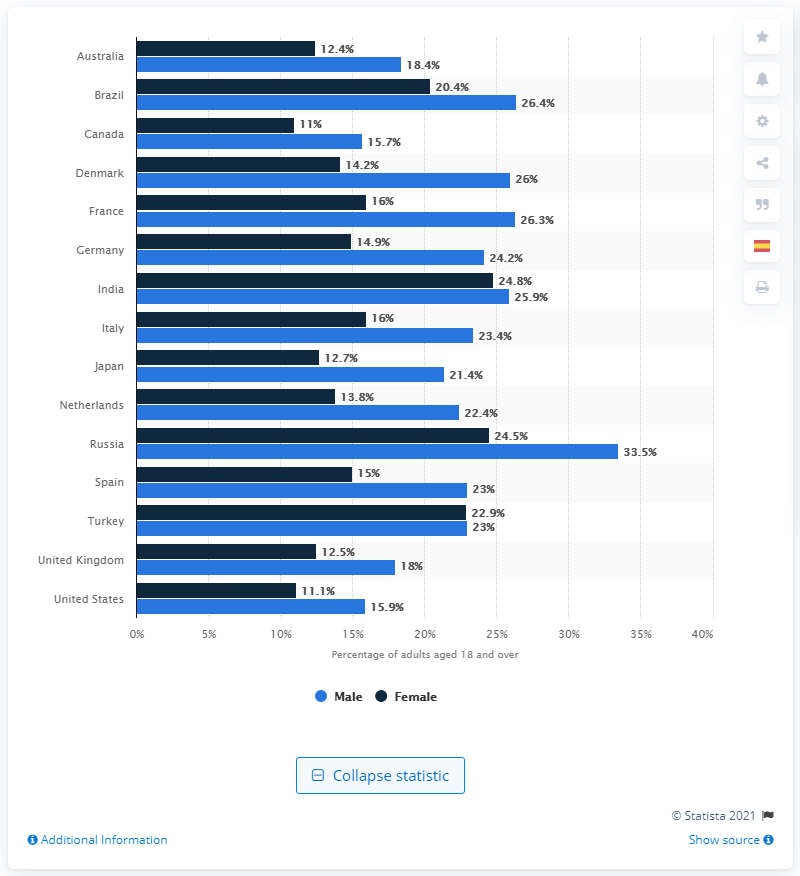Outline some significant characteristics in this image. In 2014, it was reported that 26.4% of the male population in Brazil had elevated blood pressure. 